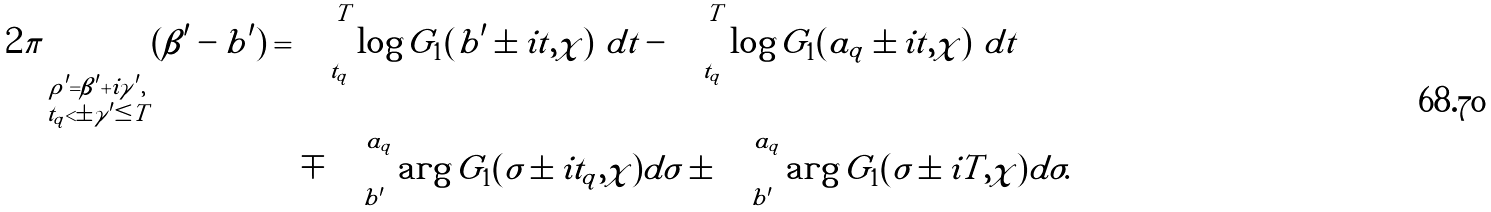Convert formula to latex. <formula><loc_0><loc_0><loc_500><loc_500>2 \pi \sum _ { \substack { \rho ^ { \prime } = \beta ^ { \prime } + i \gamma ^ { \prime } , \\ t _ { q } < \pm \gamma ^ { \prime } \leq T } } ( \beta ^ { \prime } - b ^ { \prime } ) & = \int _ { t _ { q } } ^ { T } \log { | G _ { 1 } ( b ^ { \prime } \pm i t , \chi ) | } d t - \int _ { t _ { q } } ^ { T } \log { | G _ { 1 } ( a _ { q } \pm i t , \chi ) | } d t \\ & \quad \mp \int _ { b ^ { \prime } } ^ { a _ { q } } \arg { G _ { 1 } ( \sigma \pm i t _ { q } , \chi ) } d \sigma \pm \int _ { b ^ { \prime } } ^ { a _ { q } } \arg { G _ { 1 } ( \sigma \pm i T , \chi ) } d \sigma .</formula> 